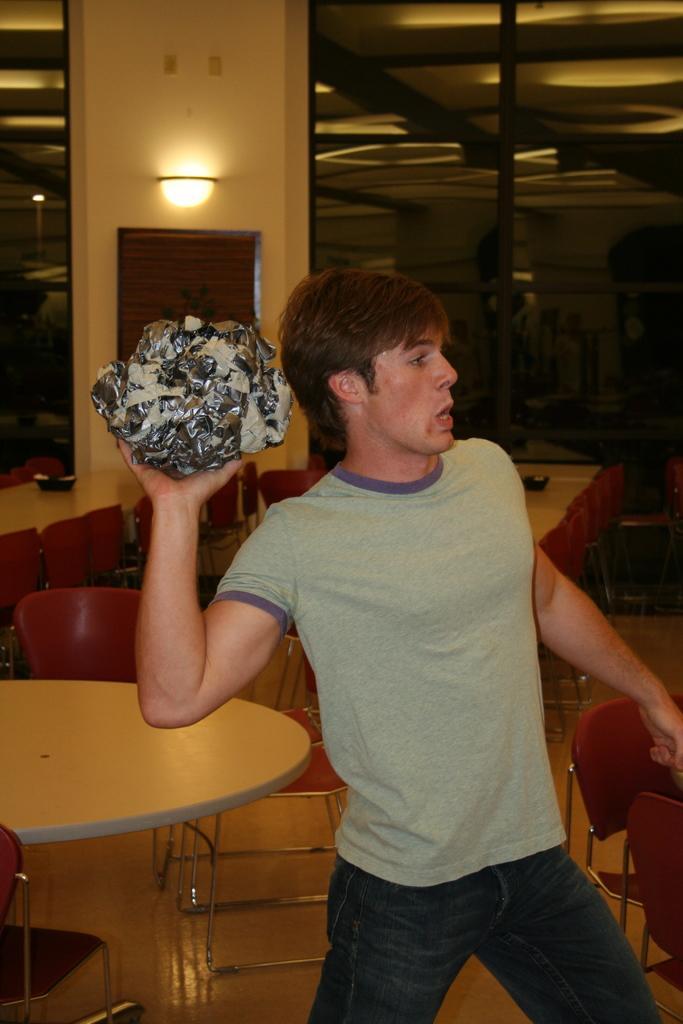In one or two sentences, can you explain what this image depicts? In this picture there is a man standing. He is holding something in his hand and is about to throw. Behind him there are many tables and chairs. In the background there is wall, window and lamp. 